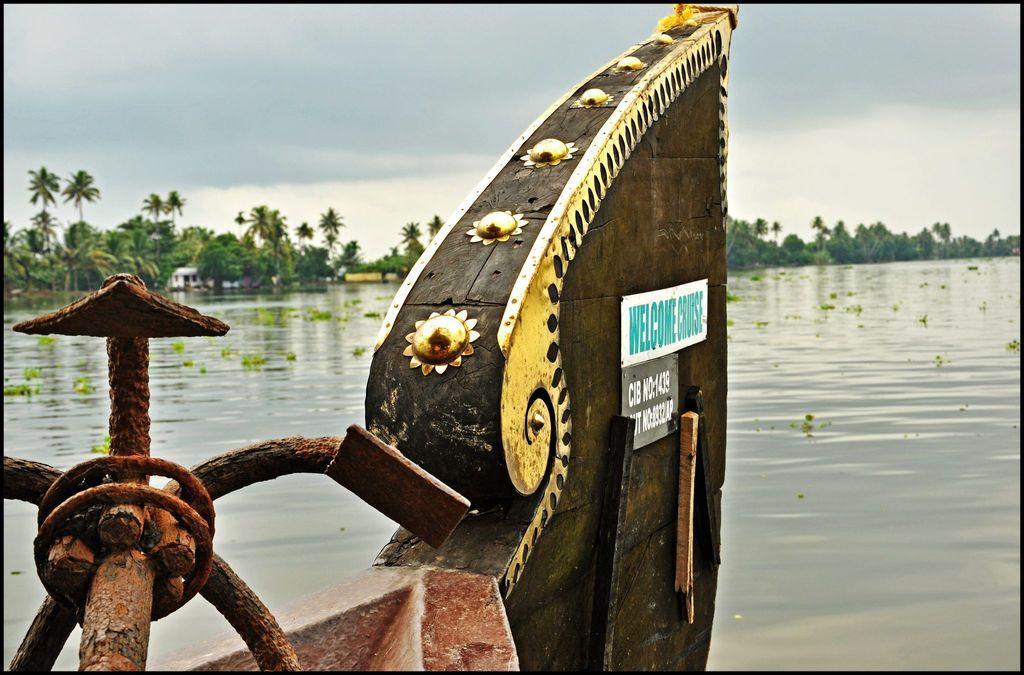Please provide a concise description of this image. In this image there is water. In the foreground there is an edge of a boat. There are boards with text on the board. There are plants on the water. In the background there are trees and houses. At the top there is the sky. In the bottom left there is a machine. 